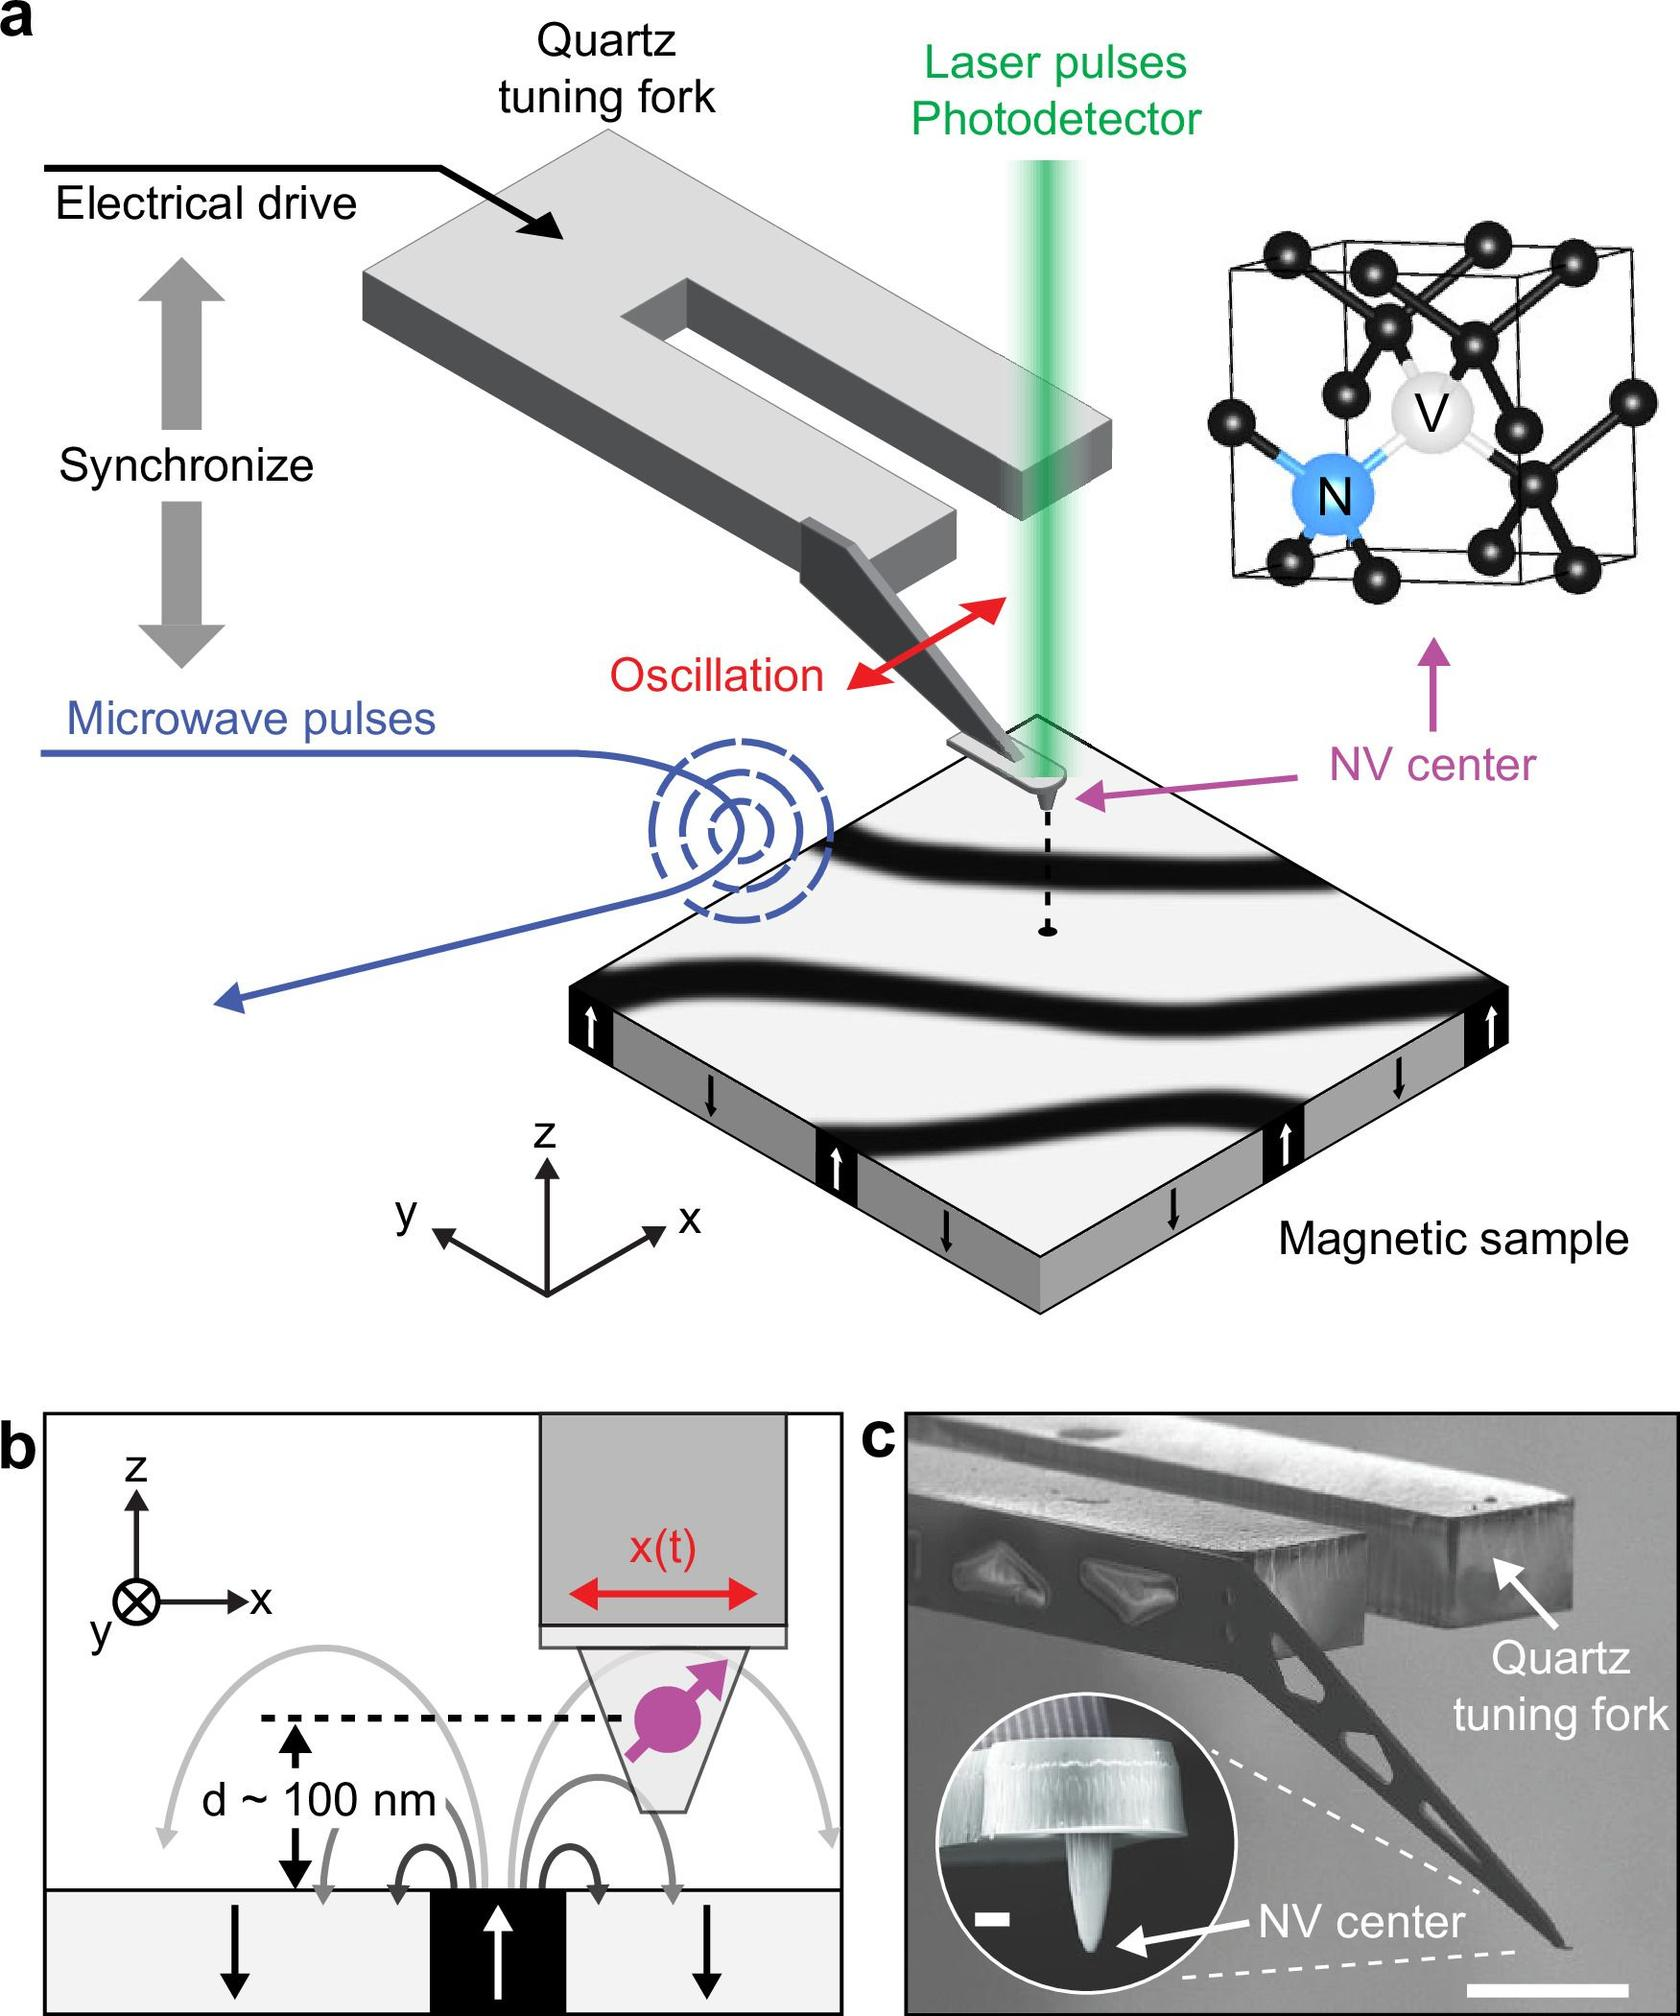How do the microwave pulses interact with the NV center in this setup? The microwave pulses in this setup are used to manipulate the spin states of the electrons in the NV center. By precisely tuning these pulses, scientists can control the electronic spin state transitions at the NV center, which is critical for measurements and detection of magnetic field variations at the microscopic level. 